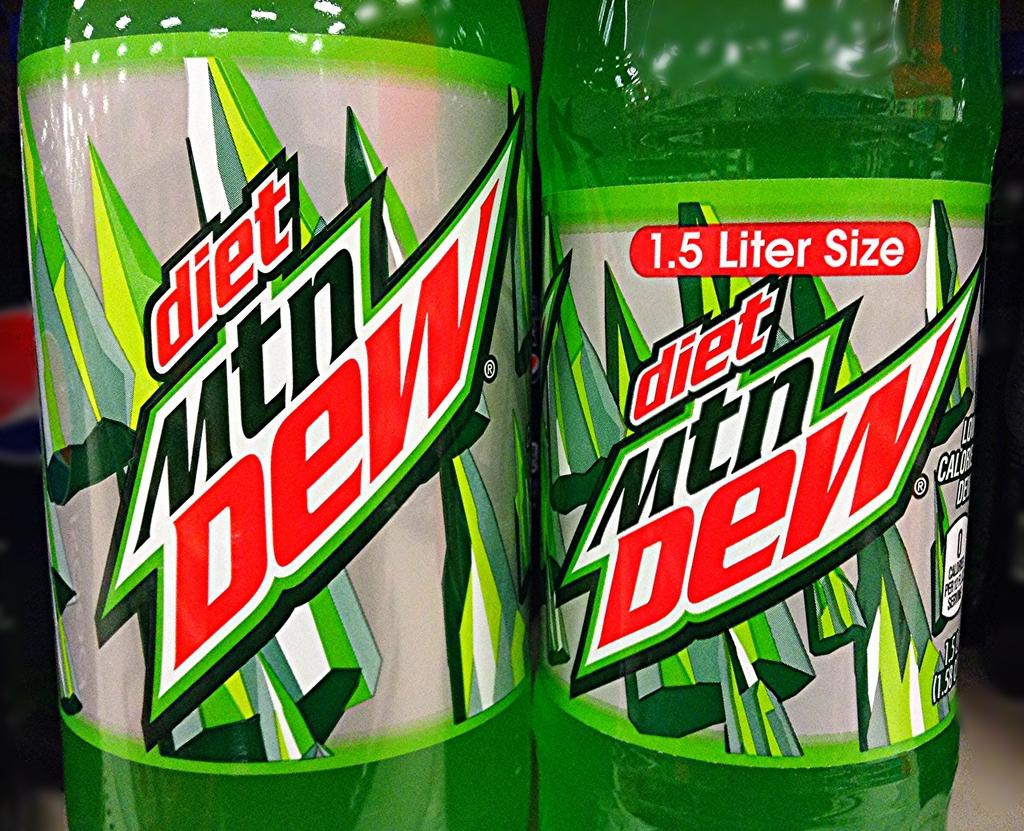<image>
Give a short and clear explanation of the subsequent image. A diet Mtn Dew bottle is 1.5 Liters in size. 